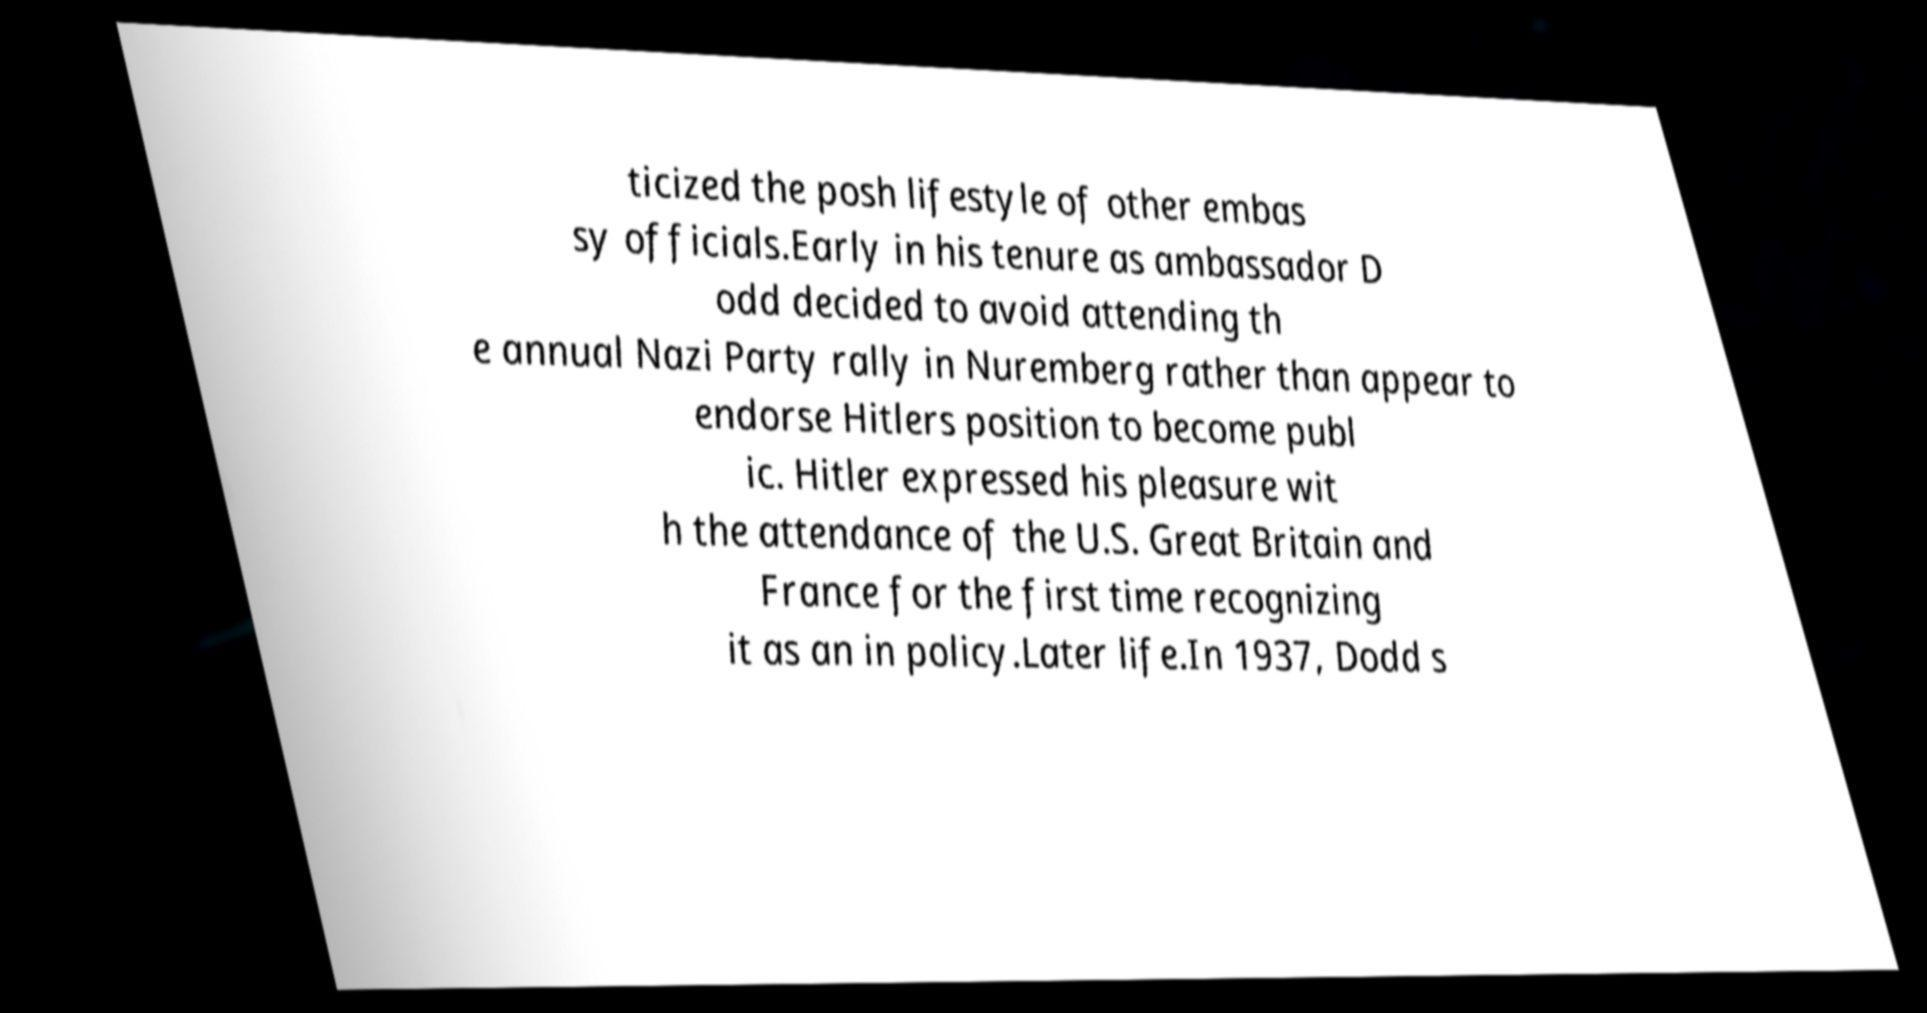For documentation purposes, I need the text within this image transcribed. Could you provide that? ticized the posh lifestyle of other embas sy officials.Early in his tenure as ambassador D odd decided to avoid attending th e annual Nazi Party rally in Nuremberg rather than appear to endorse Hitlers position to become publ ic. Hitler expressed his pleasure wit h the attendance of the U.S. Great Britain and France for the first time recognizing it as an in policy.Later life.In 1937, Dodd s 